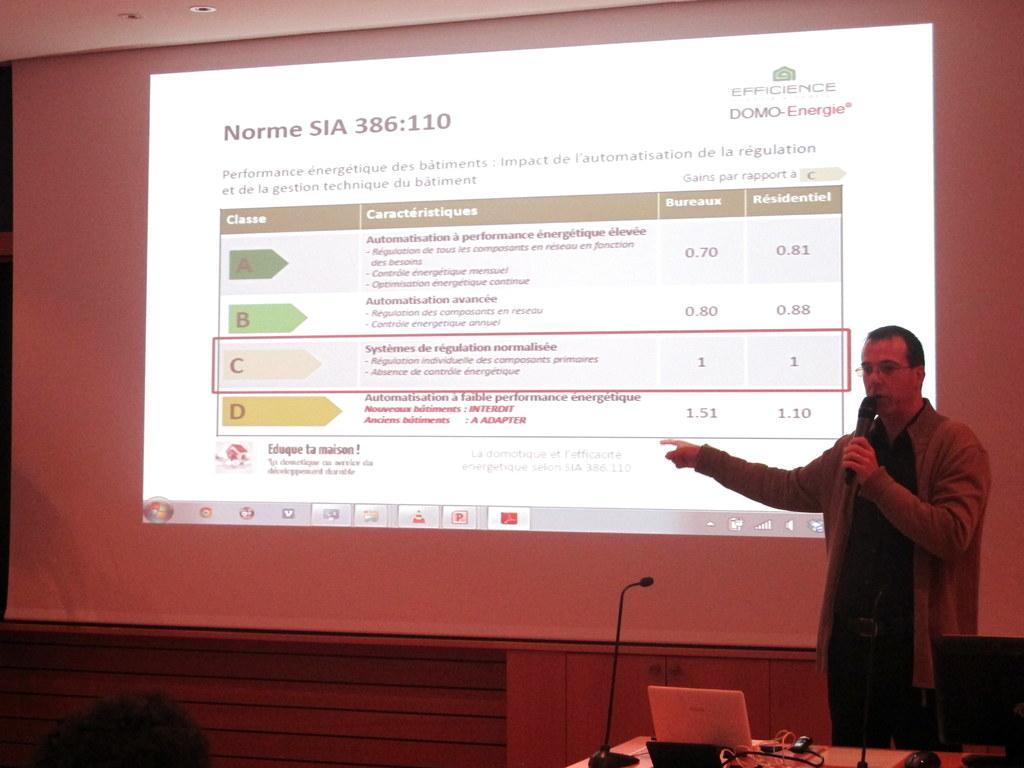How would you summarize this image in a sentence or two? In this image we can see a man holding a microphone in his hand is standing. In the foreground of the image we can see laptop, microphones, mouse and a monitor placed on the table, we can also see a person. At the top of the image we can see the projector screen with some text on it. 